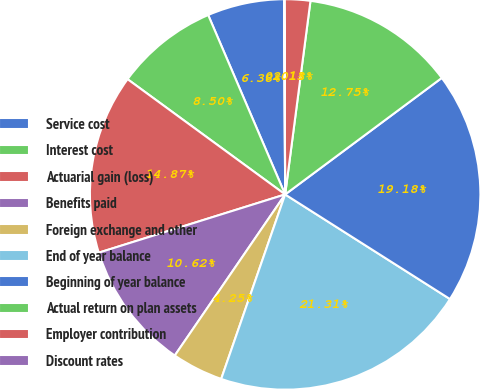Convert chart. <chart><loc_0><loc_0><loc_500><loc_500><pie_chart><fcel>Service cost<fcel>Interest cost<fcel>Actuarial gain (loss)<fcel>Benefits paid<fcel>Foreign exchange and other<fcel>End of year balance<fcel>Beginning of year balance<fcel>Actual return on plan assets<fcel>Employer contribution<fcel>Discount rates<nl><fcel>6.38%<fcel>8.5%<fcel>14.87%<fcel>10.62%<fcel>4.25%<fcel>21.31%<fcel>19.18%<fcel>12.75%<fcel>2.13%<fcel>0.01%<nl></chart> 